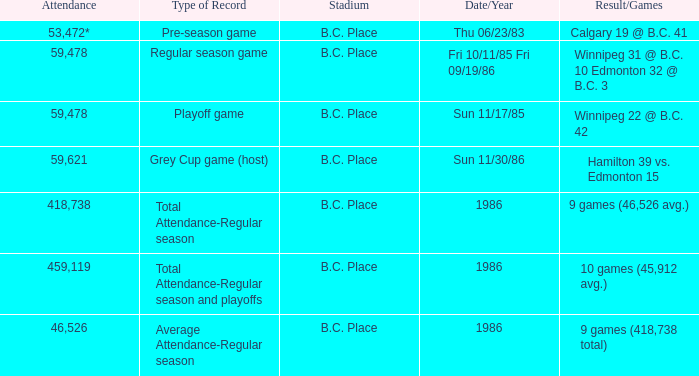What was the stadium that had the regular season game? B.C. Place. Parse the table in full. {'header': ['Attendance', 'Type of Record', 'Stadium', 'Date/Year', 'Result/Games'], 'rows': [['53,472*', 'Pre-season game', 'B.C. Place', 'Thu 06/23/83', 'Calgary 19 @ B.C. 41'], ['59,478', 'Regular season game', 'B.C. Place', 'Fri 10/11/85 Fri 09/19/86', 'Winnipeg 31 @ B.C. 10 Edmonton 32 @ B.C. 3'], ['59,478', 'Playoff game', 'B.C. Place', 'Sun 11/17/85', 'Winnipeg 22 @ B.C. 42'], ['59,621', 'Grey Cup game (host)', 'B.C. Place', 'Sun 11/30/86', 'Hamilton 39 vs. Edmonton 15'], ['418,738', 'Total Attendance-Regular season', 'B.C. Place', '1986', '9 games (46,526 avg.)'], ['459,119', 'Total Attendance-Regular season and playoffs', 'B.C. Place', '1986', '10 games (45,912 avg.)'], ['46,526', 'Average Attendance-Regular season', 'B.C. Place', '1986', '9 games (418,738 total)']]} 